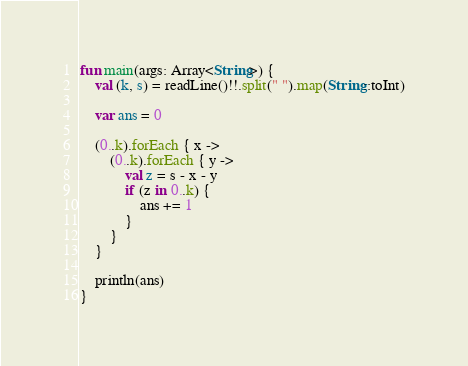Convert code to text. <code><loc_0><loc_0><loc_500><loc_500><_Kotlin_>fun main(args: Array<String>) {
    val (k, s) = readLine()!!.split(" ").map(String::toInt)

    var ans = 0
    
    (0..k).forEach { x ->
        (0..k).forEach { y ->
            val z = s - x - y
            if (z in 0..k) {
                ans += 1
            }
        }
    }

    println(ans)
}</code> 